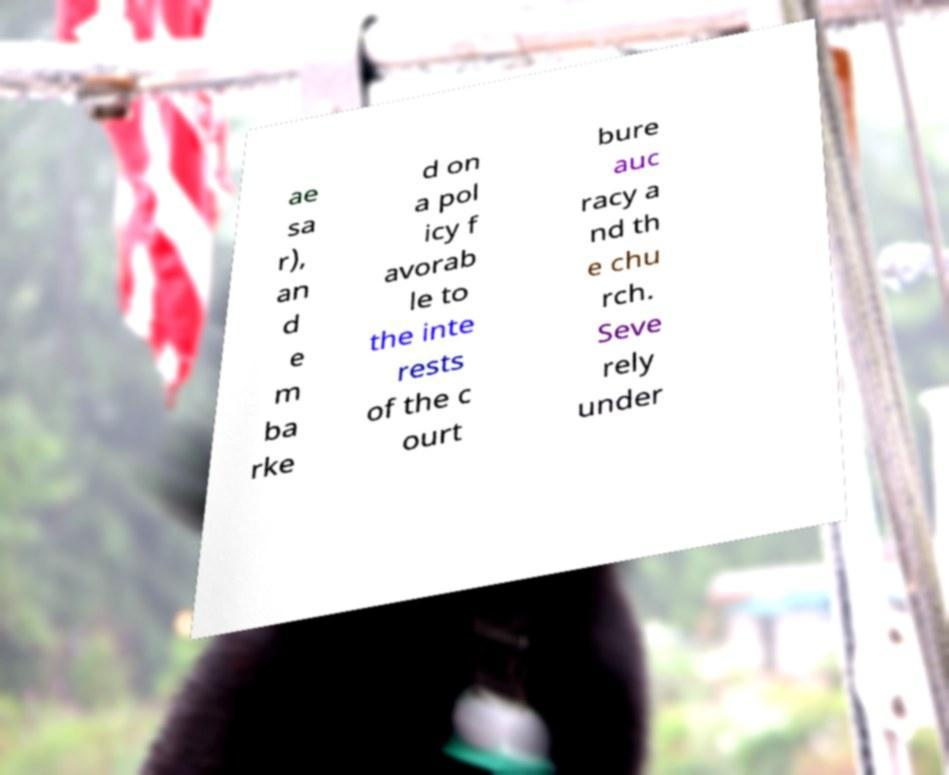Could you extract and type out the text from this image? ae sa r), an d e m ba rke d on a pol icy f avorab le to the inte rests of the c ourt bure auc racy a nd th e chu rch. Seve rely under 